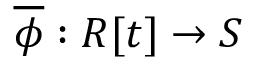<formula> <loc_0><loc_0><loc_500><loc_500>{ \overline { \phi } } \colon R [ t ] \to S</formula> 